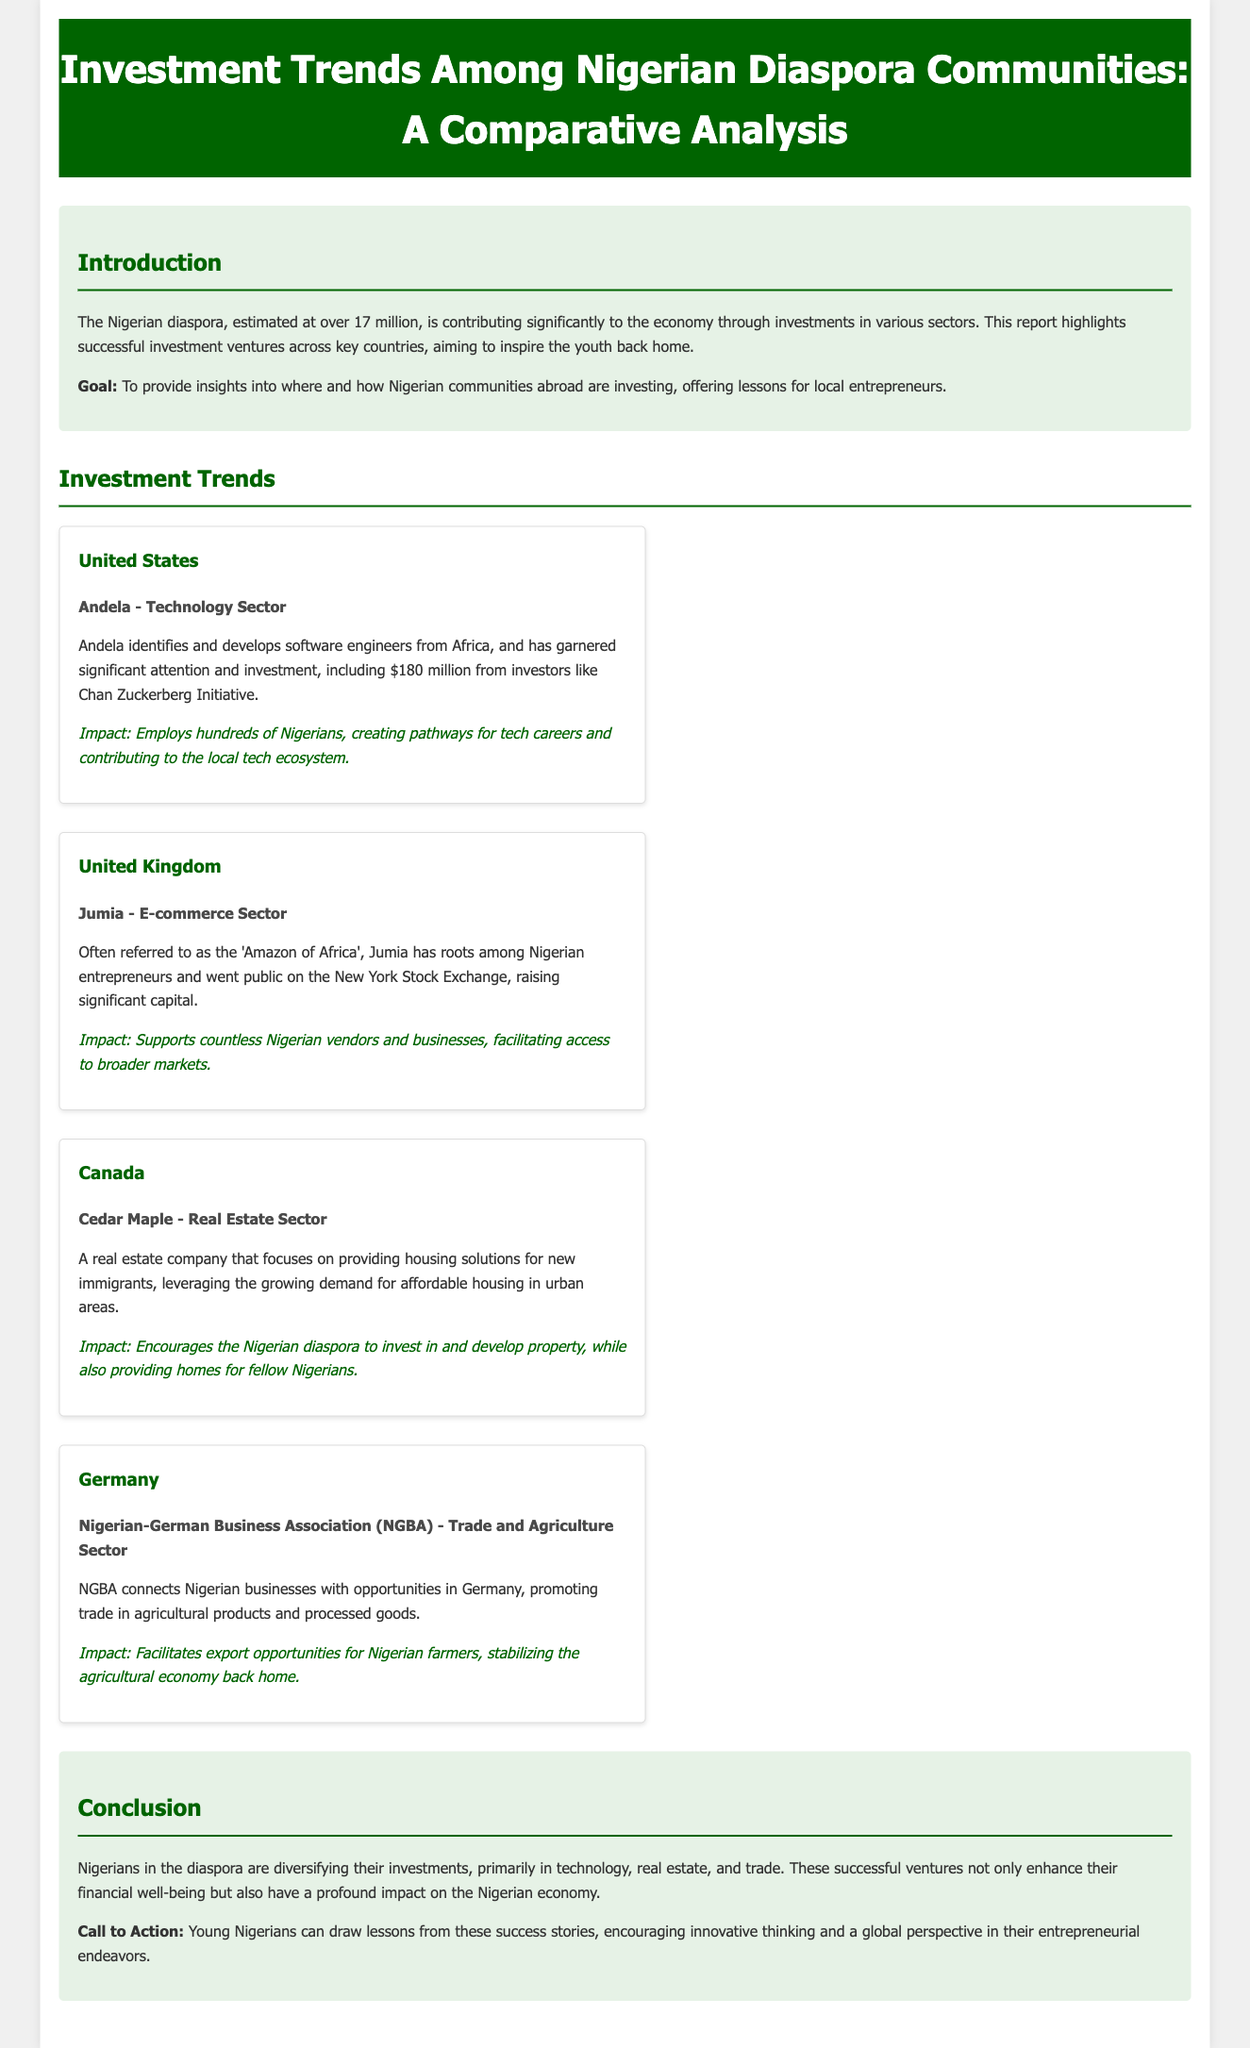What is the estimated number of the Nigerian diaspora? The document states that the Nigerian diaspora is estimated at over 17 million.
Answer: over 17 million What is the name of the real estate company in Canada? The document refers to Cedar Maple as the real estate company that focuses on providing housing solutions for new immigrants.
Answer: Cedar Maple Which Nigerian startup was highlighted in the United States? The document mentions Andela as the highlighted Nigerian startup in the United States.
Answer: Andela What sector does Jumia operate in? According to the document, Jumia operates in the e-commerce sector.
Answer: E-commerce What is the impact of the NGBA according to the report? The document states that the impact of the NGBA facilitates export opportunities for Nigerian farmers, stabilizing the agricultural economy back home.
Answer: Facilitates export opportunities What industry does Cedar Maple focus on? The document indicates that Cedar Maple focuses on the real estate sector.
Answer: Real estate In which country did the 'Amazon of Africa' go public? The document mentions that Jumia, referred to as the 'Amazon of Africa', went public on the New York Stock Exchange.
Answer: United States How does Andela contribute to the local tech ecosystem? The document explains that Andela employs hundreds of Nigerians, creating pathways for tech careers.
Answer: Employs hundreds of Nigerians 